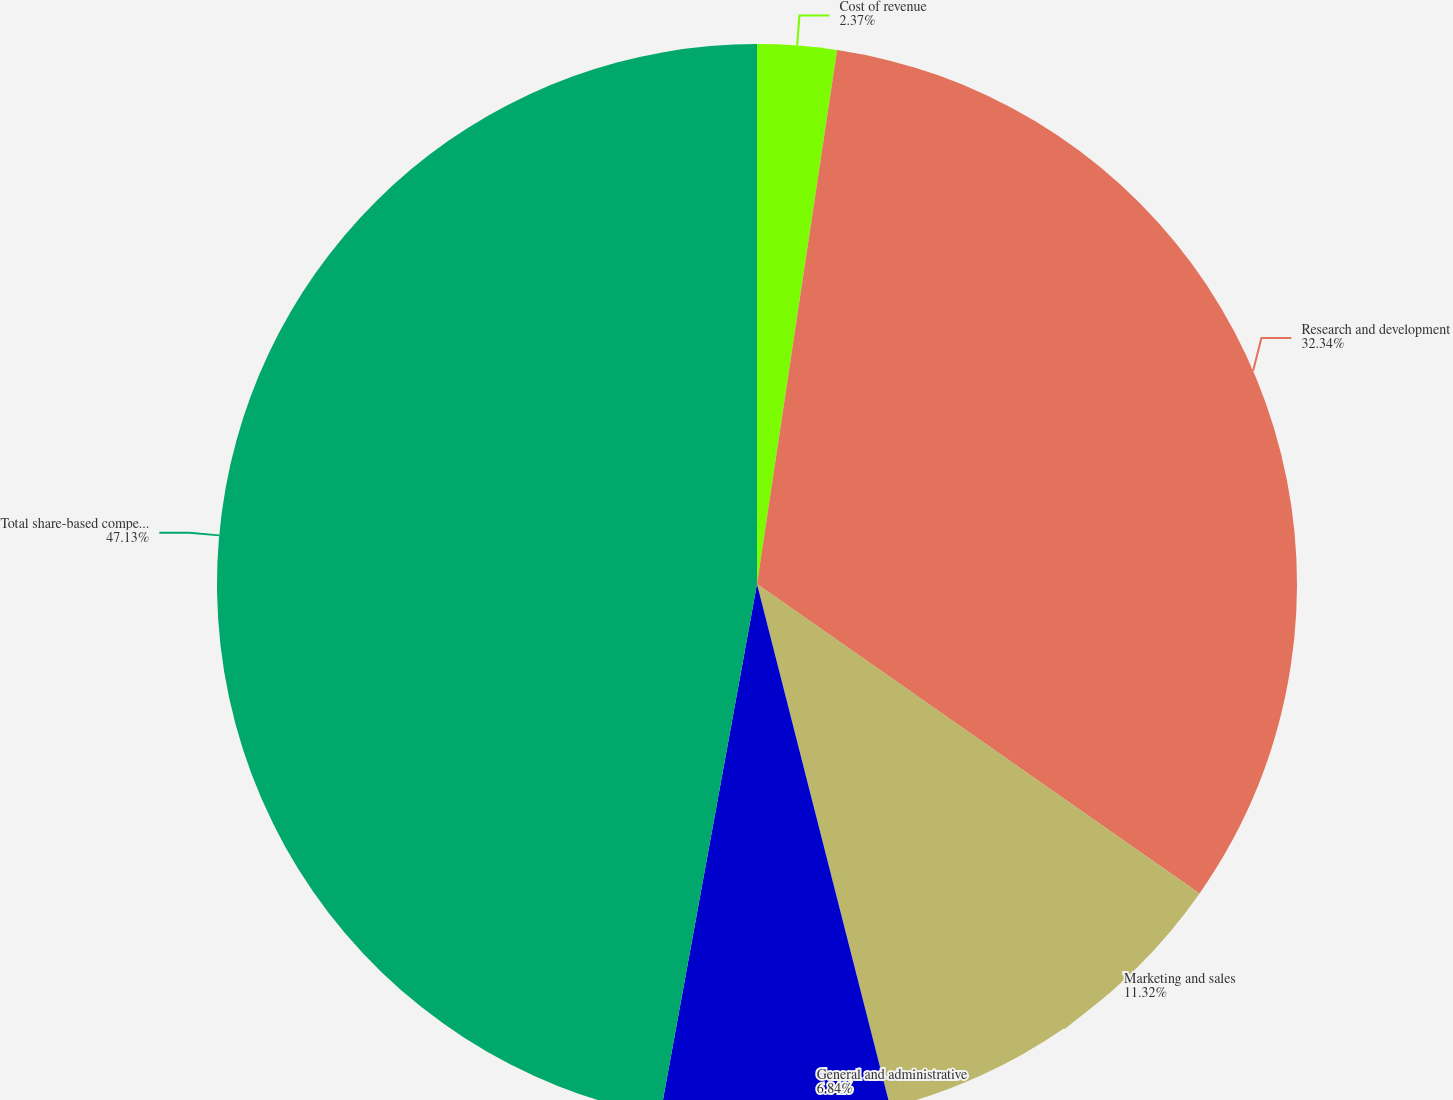Convert chart to OTSL. <chart><loc_0><loc_0><loc_500><loc_500><pie_chart><fcel>Cost of revenue<fcel>Research and development<fcel>Marketing and sales<fcel>General and administrative<fcel>Total share-based compensation<nl><fcel>2.37%<fcel>32.34%<fcel>11.32%<fcel>6.84%<fcel>47.13%<nl></chart> 